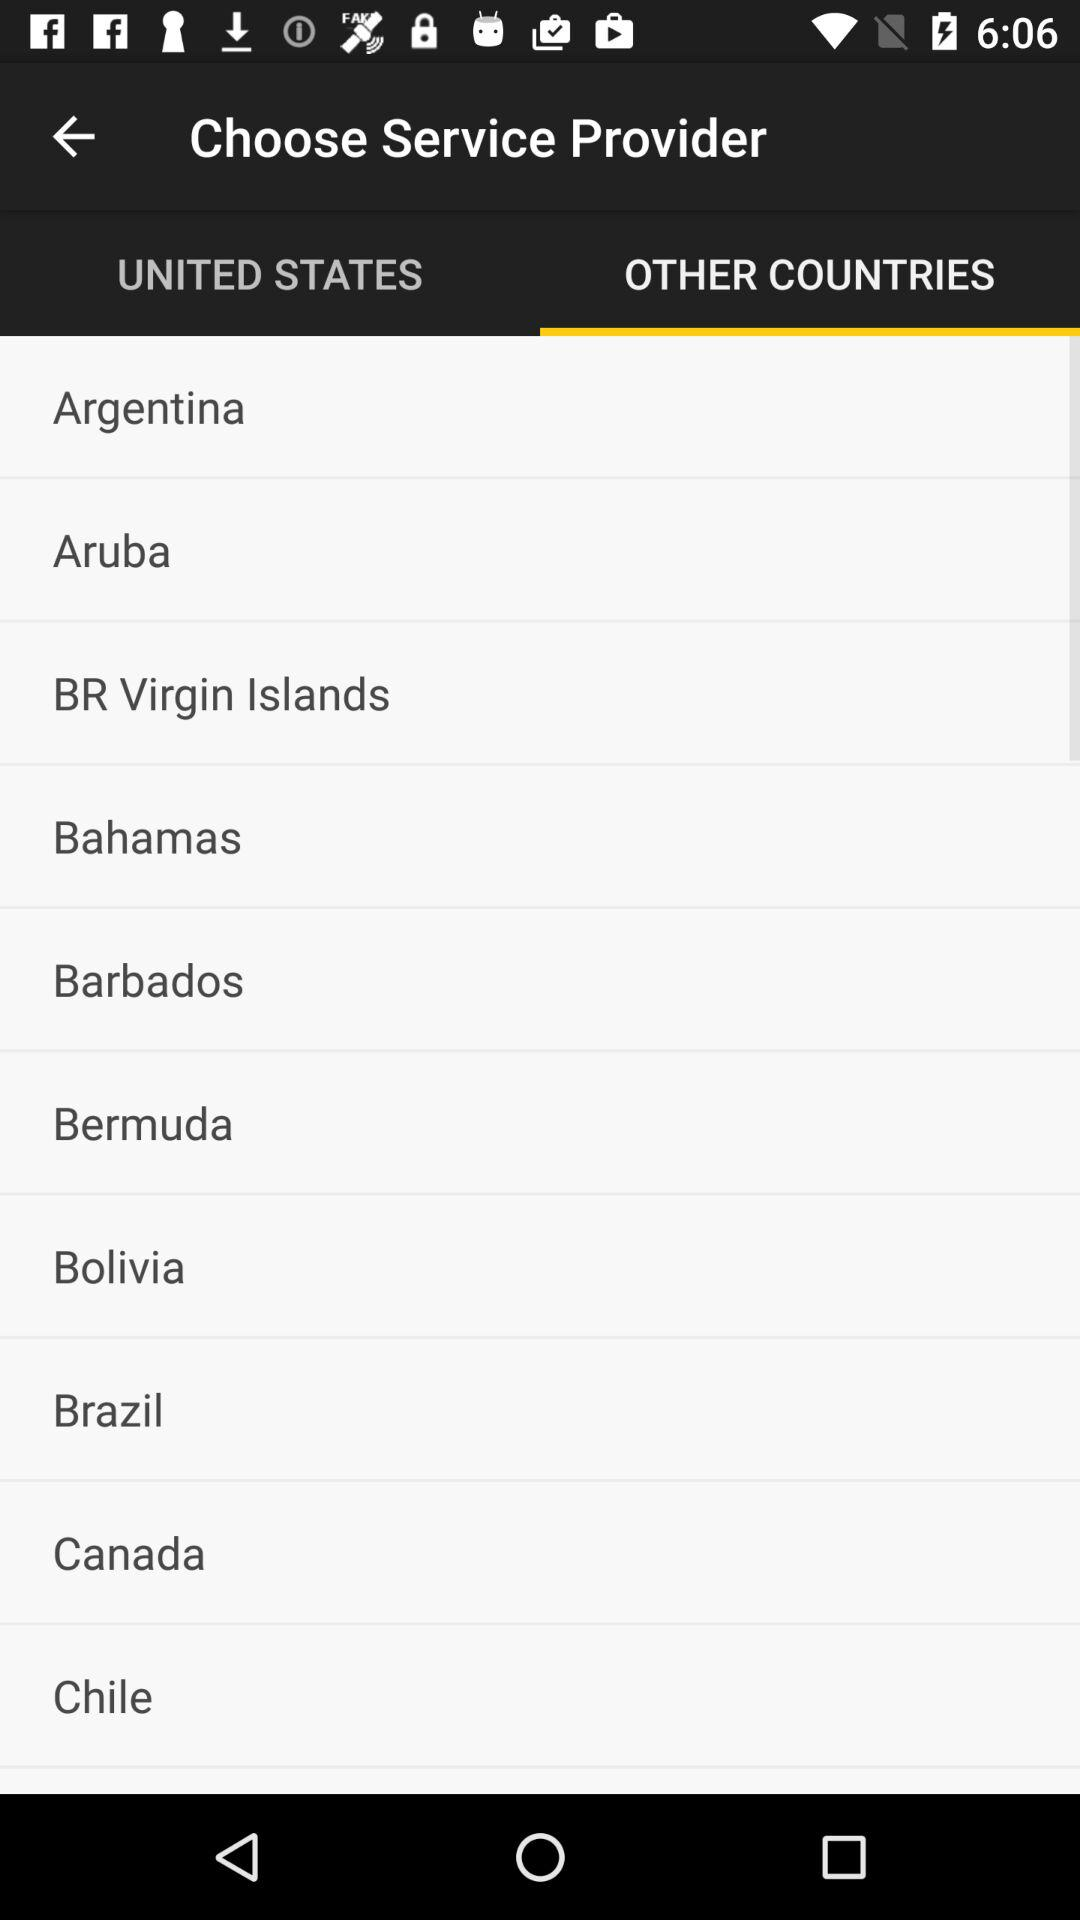What are the available countries in the list? The options are "Argentina", "Aruba", "BR Virgin Islands", "Bahamas", "Barbados", "Bermuda", "Bolivia", "Brazil", "Canada" and "Chile". 